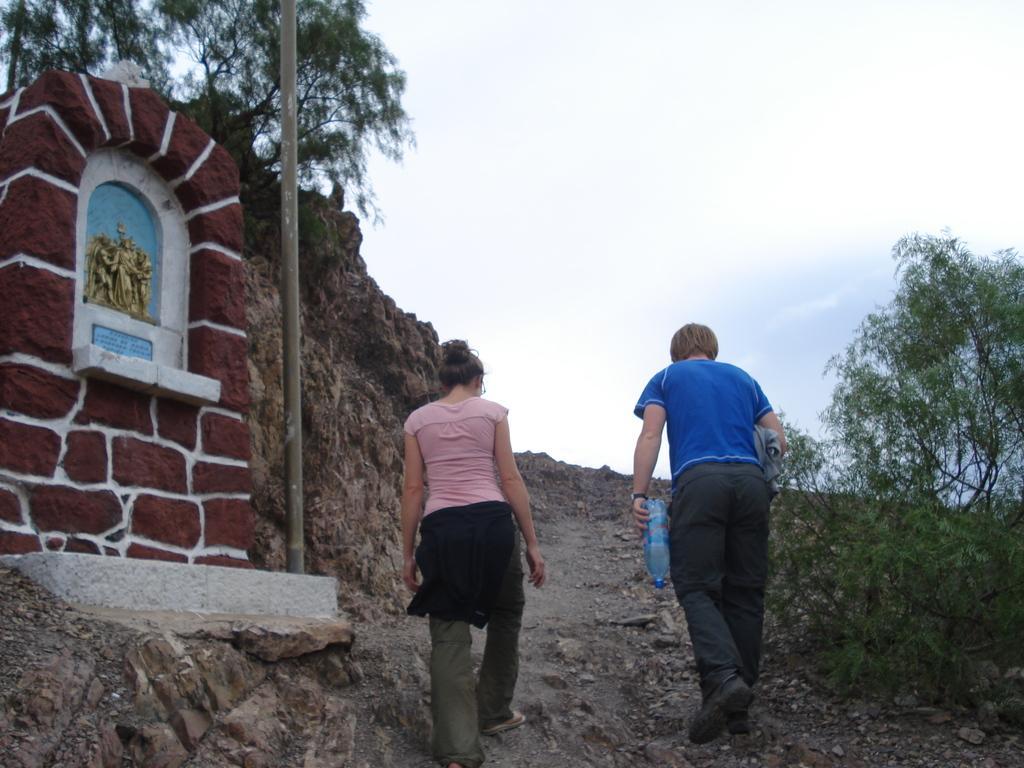In one or two sentences, can you explain what this image depicts? In this image I can see in the middle two persons are walking, on the left side there is a statue. There are trees on either side in this image, at the top it is the sky. 